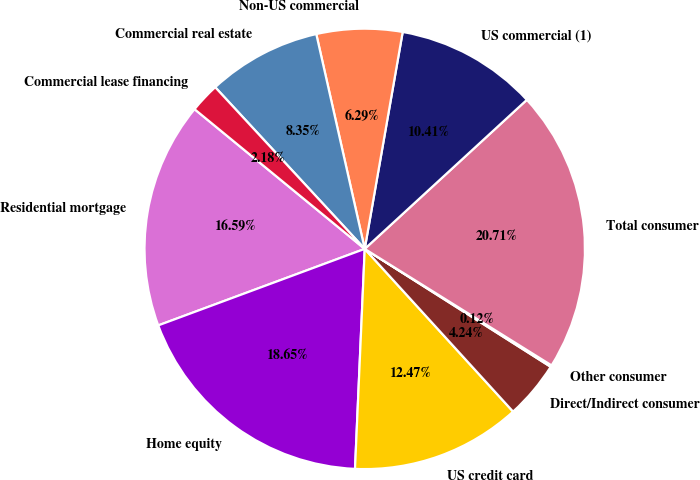Convert chart to OTSL. <chart><loc_0><loc_0><loc_500><loc_500><pie_chart><fcel>Residential mortgage<fcel>Home equity<fcel>US credit card<fcel>Direct/Indirect consumer<fcel>Other consumer<fcel>Total consumer<fcel>US commercial (1)<fcel>Non-US commercial<fcel>Commercial real estate<fcel>Commercial lease financing<nl><fcel>16.59%<fcel>18.65%<fcel>12.47%<fcel>4.24%<fcel>0.12%<fcel>20.71%<fcel>10.41%<fcel>6.29%<fcel>8.35%<fcel>2.18%<nl></chart> 